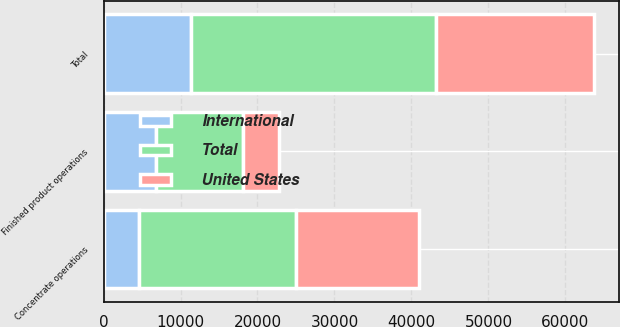<chart> <loc_0><loc_0><loc_500><loc_500><stacked_bar_chart><ecel><fcel>Concentrate operations<fcel>Finished product operations<fcel>Total<nl><fcel>International<fcel>4571<fcel>6773<fcel>11344<nl><fcel>United States<fcel>15886<fcel>4626<fcel>20512<nl><fcel>Total<fcel>20457<fcel>11399<fcel>31856<nl></chart> 